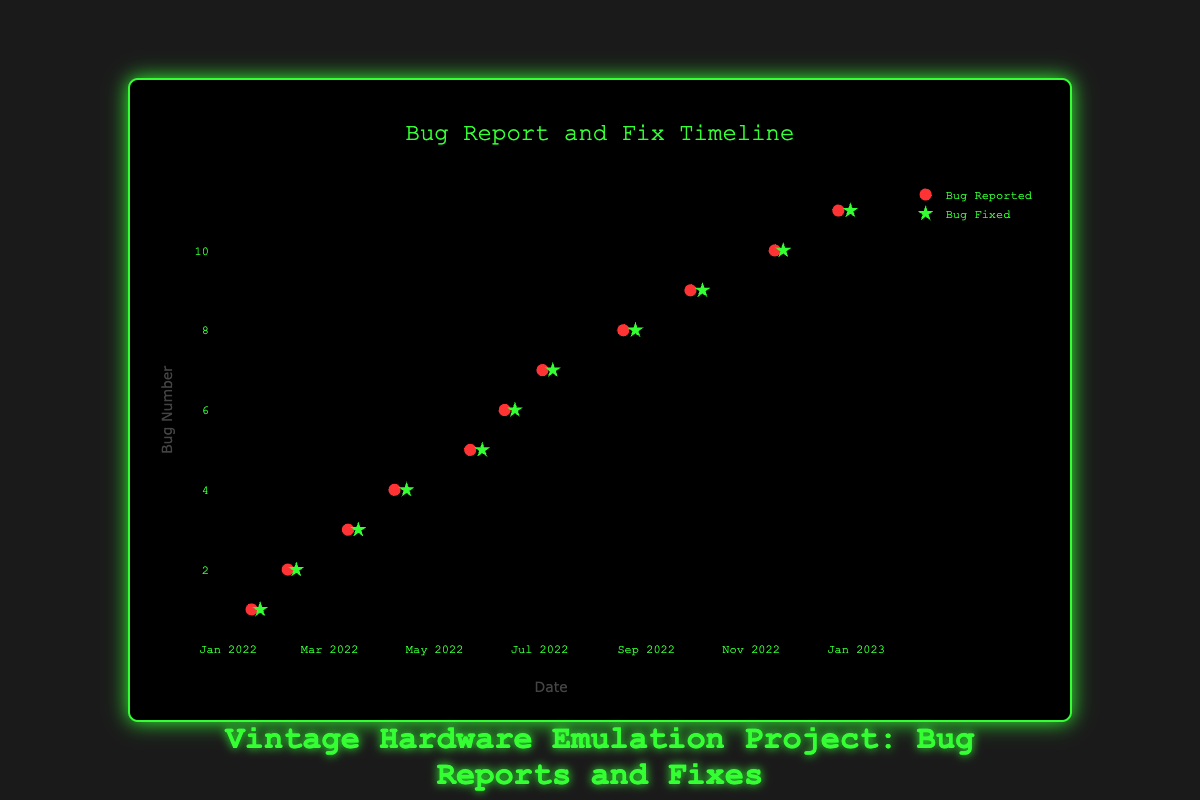What is the title of the figure? The title of the figure is typically located above the chart and is used to quickly convey the main topic or focus of the visualization.
Answer: Vintage Hardware Emulation Project: Bug Reports and Fixes How many bugs were reported in total throughout the period? Count the number of distinct bug report data points represented by red circles on the plot. There are 11 distinct red circles representing 11 bug reports.
Answer: 11 Which month had the most rapid bug fix, and what was the duration between the bug report and fix? To identify the month, locate the shortest time interval between red circles (bug reports) and corresponding green stars (bug fixes) on the x-axis. Compare durations to determine which is shortest. The March bug was reported on March 12 and fixed on March 18, taking only 6 days.
Answer: March, 6 days Were any bugs reported in the months of June or July, and if so, were they fixed faster or slower compared to other months? Check for data points in June and July. There were bugs reported in both months: June 11 (fixed on June 17 in 6 days) and July 3 (fixed on July 9 in 6 days). Compare these to other intervals; since some fixes took longer, these intervals are relatively faster.
Answer: Yes, fixed faster Which bug had the longest interval between the report date and fix date? By comparing all bug report-fix date intervals, identify which pair has the longest duration. Here, the bug reported on September 27 and fixed on October 4 took 7 days, the longest among the given data.
Answer: Input device lag (September 27 to October 4) What is the average duration taken to fix a bug during the year 2022? Sum all fix durations: (5+5+6+7+7+6+6+7+7+5+7) = 68 days, and divide by the number of bugs (11). 68/11 gives an average fixing time of approximately 6.18 days.
Answer: Approximately 6.18 days Compare the number of bugs fixed within 7 days to those that took more than 7 days. Identify and count all bugs fixed within or exactly 7 days and those taking longer. Bugs fixed within 7 days: 11; bugs fixed taking longer: 0. No fixes took over 7 days.
Answer: 11:0 (All fixed within 7 days) 